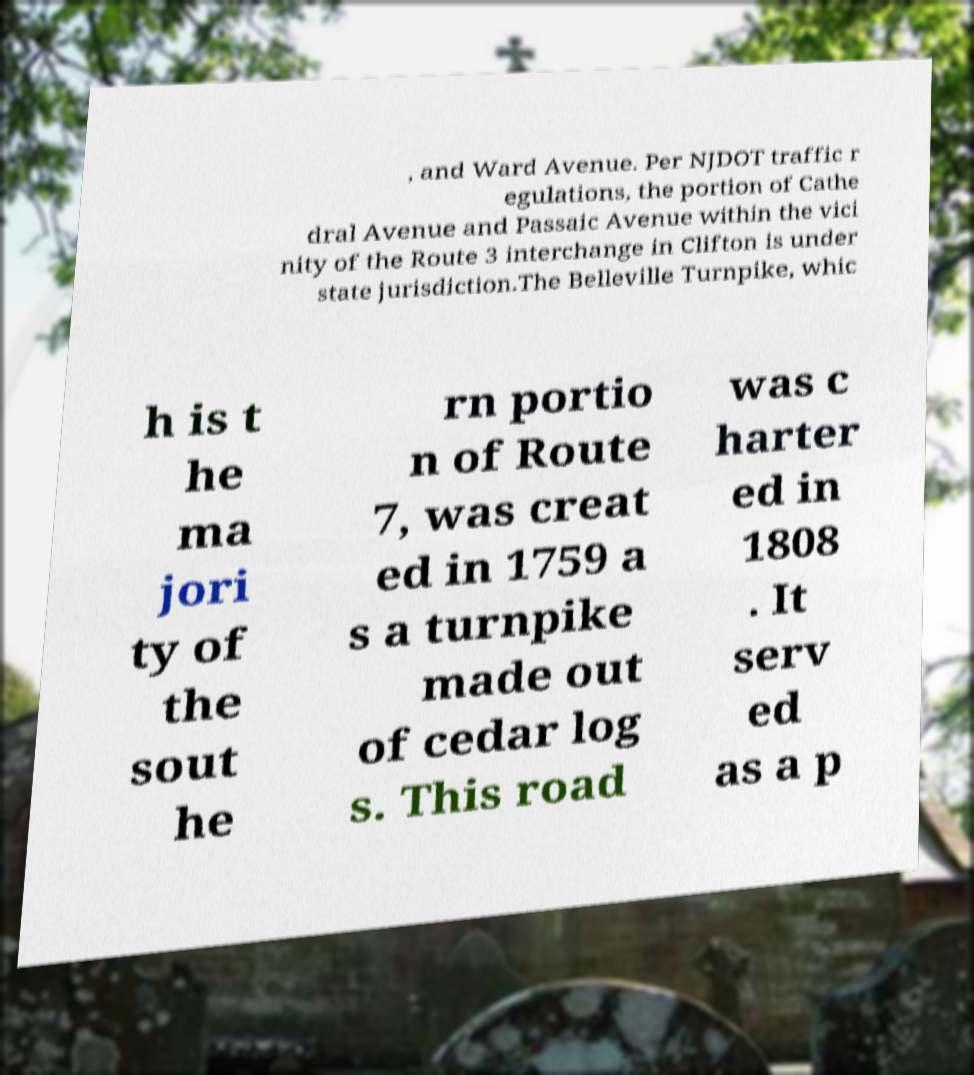Please read and relay the text visible in this image. What does it say? , and Ward Avenue. Per NJDOT traffic r egulations, the portion of Cathe dral Avenue and Passaic Avenue within the vici nity of the Route 3 interchange in Clifton is under state jurisdiction.The Belleville Turnpike, whic h is t he ma jori ty of the sout he rn portio n of Route 7, was creat ed in 1759 a s a turnpike made out of cedar log s. This road was c harter ed in 1808 . It serv ed as a p 